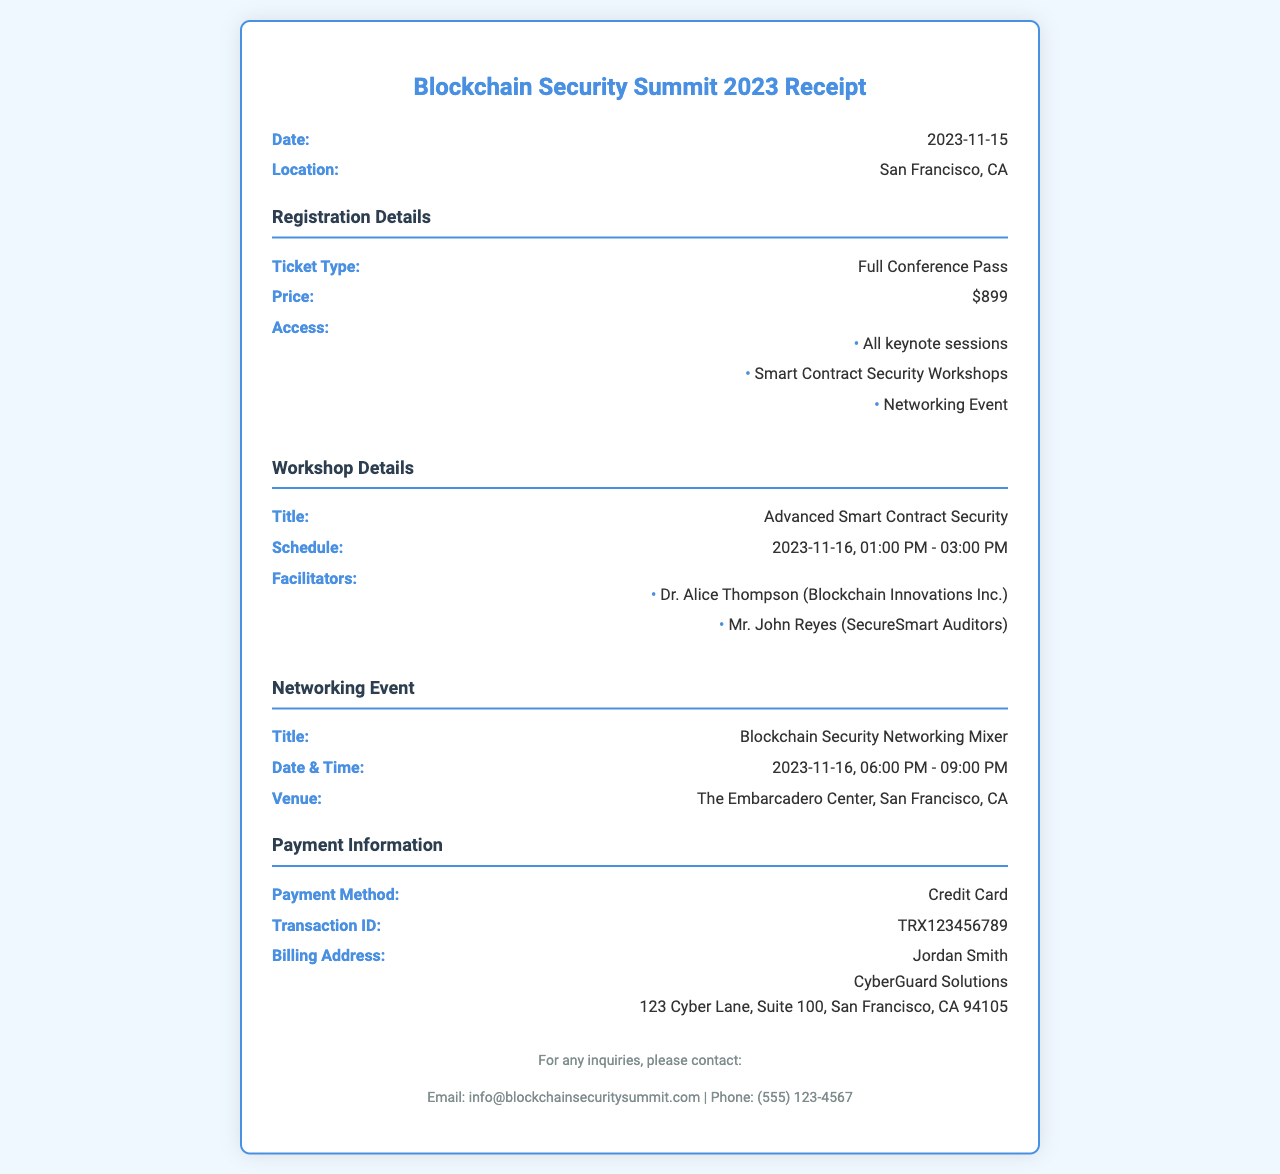What is the ticket type? The ticket type listed in the document specifies what kind of entry the registrant has at the conference.
Answer: Full Conference Pass What is the date of the conference? This refers to the main event date provided in the receipt.
Answer: 2023-11-15 Who are the facilitators of the workshop? This question seeks the names of individuals leading the workshop on smart contract security.
Answer: Dr. Alice Thompson (Blockchain Innovations Inc.), Mr. John Reyes (SecureSmart Auditors) What time does the networking event start? This question requires finding the start time for the networking event listed in the document.
Answer: 06:00 PM What is the location of the networking event? This question asks for the specific place where the networking event will take place as per the document.
Answer: The Embarcadero Center, San Francisco, CA What is the price of the full conference pass? The document lists the cost associated with the ticket type registration.
Answer: $899 When is the workshop scheduled? Here, the question asks for the exact date and time that the workshop will occur, as stated in the document.
Answer: 2023-11-16, 01:00 PM - 03:00 PM What payment method was used? This question seeks to identify the method of payment for registration as provided in the receipt.
Answer: Credit Card What is the transaction ID? The transaction ID is a unique identifier for the payment that is recorded on the receipt.
Answer: TRX123456789 